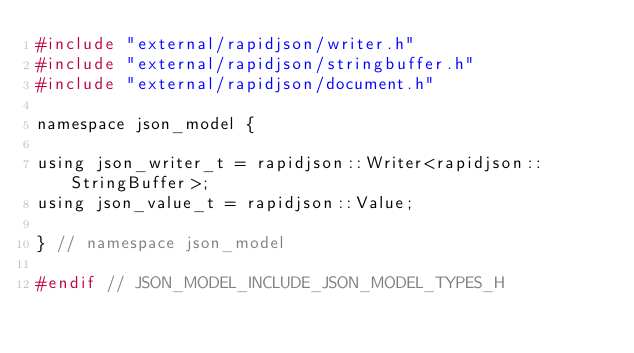Convert code to text. <code><loc_0><loc_0><loc_500><loc_500><_C_>#include "external/rapidjson/writer.h"
#include "external/rapidjson/stringbuffer.h"
#include "external/rapidjson/document.h"

namespace json_model {

using json_writer_t = rapidjson::Writer<rapidjson::StringBuffer>;
using json_value_t = rapidjson::Value;

} // namespace json_model

#endif // JSON_MODEL_INCLUDE_JSON_MODEL_TYPES_H
</code> 